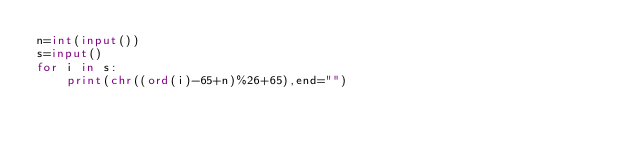<code> <loc_0><loc_0><loc_500><loc_500><_Python_>n=int(input())
s=input()
for i in s:
    print(chr((ord(i)-65+n)%26+65),end="")
</code> 